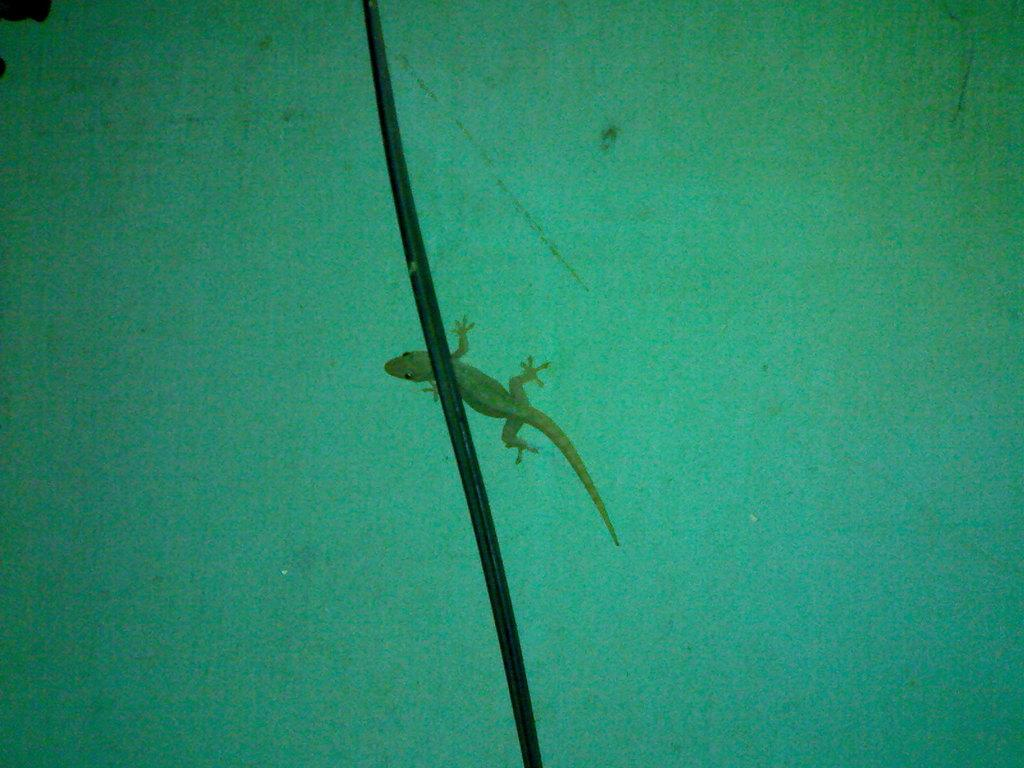What type of animal is in the image? There is a lizard in the image. Where is the lizard located? The lizard is on a wall. What is in front of the lizard? There is a cable in front of the lizard. What is the lizard using to comfort itself in the image? There is no indication in the image that the lizard is seeking comfort or using any object for that purpose. 